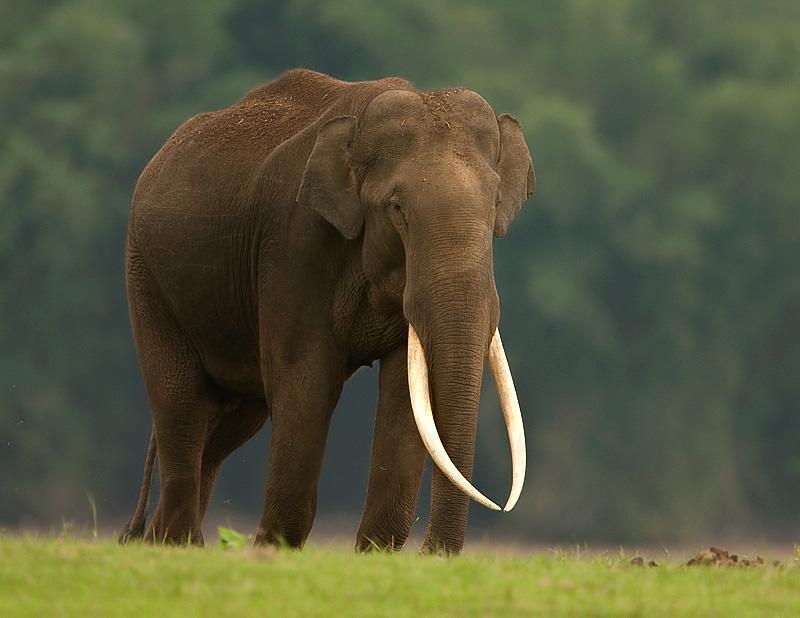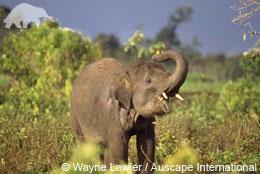The first image is the image on the left, the second image is the image on the right. Analyze the images presented: Is the assertion "There is at least one elephant lifting its trunk in the air." valid? Answer yes or no. Yes. The first image is the image on the left, the second image is the image on the right. Evaluate the accuracy of this statement regarding the images: "At least one elephant has it's trunk raised in one image.". Is it true? Answer yes or no. Yes. 